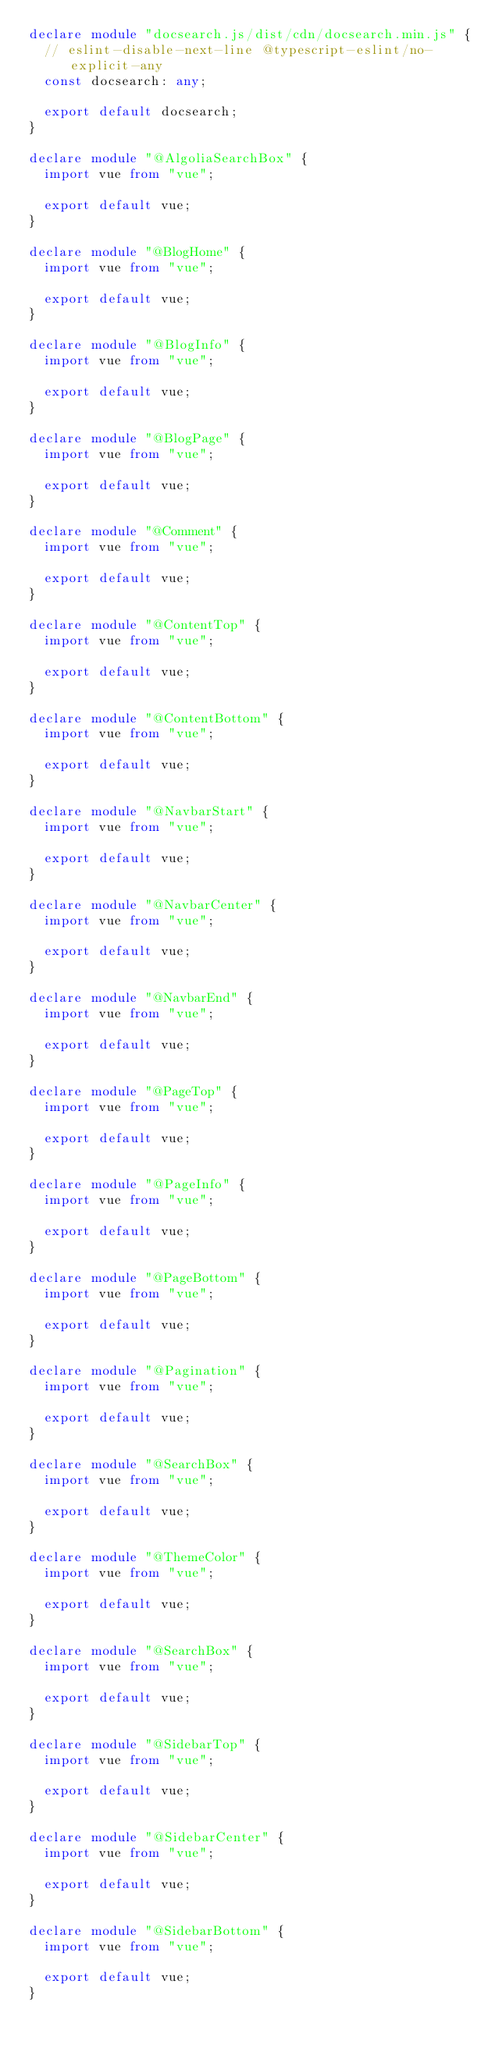<code> <loc_0><loc_0><loc_500><loc_500><_TypeScript_>declare module "docsearch.js/dist/cdn/docsearch.min.js" {
  // eslint-disable-next-line @typescript-eslint/no-explicit-any
  const docsearch: any;

  export default docsearch;
}

declare module "@AlgoliaSearchBox" {
  import vue from "vue";

  export default vue;
}

declare module "@BlogHome" {
  import vue from "vue";

  export default vue;
}

declare module "@BlogInfo" {
  import vue from "vue";

  export default vue;
}

declare module "@BlogPage" {
  import vue from "vue";

  export default vue;
}

declare module "@Comment" {
  import vue from "vue";

  export default vue;
}

declare module "@ContentTop" {
  import vue from "vue";

  export default vue;
}

declare module "@ContentBottom" {
  import vue from "vue";

  export default vue;
}

declare module "@NavbarStart" {
  import vue from "vue";

  export default vue;
}

declare module "@NavbarCenter" {
  import vue from "vue";

  export default vue;
}

declare module "@NavbarEnd" {
  import vue from "vue";

  export default vue;
}

declare module "@PageTop" {
  import vue from "vue";

  export default vue;
}

declare module "@PageInfo" {
  import vue from "vue";

  export default vue;
}

declare module "@PageBottom" {
  import vue from "vue";

  export default vue;
}

declare module "@Pagination" {
  import vue from "vue";

  export default vue;
}

declare module "@SearchBox" {
  import vue from "vue";

  export default vue;
}

declare module "@ThemeColor" {
  import vue from "vue";

  export default vue;
}

declare module "@SearchBox" {
  import vue from "vue";

  export default vue;
}

declare module "@SidebarTop" {
  import vue from "vue";

  export default vue;
}

declare module "@SidebarCenter" {
  import vue from "vue";

  export default vue;
}

declare module "@SidebarBottom" {
  import vue from "vue";

  export default vue;
}
</code> 